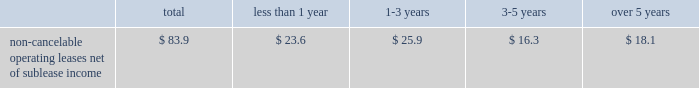Building .
The construction of the building was completed in december 2003 .
Due to lower than expected financing and construction costs , the final lease balance was lowered to $ 103.0 million .
As part of the agreement , we entered into a five-year lease that began upon the completion of the building .
At the end of the lease term , we can purchase the building for the lease balance , remarket or relinquish the building .
If we choose to remarket or are required to do so upon relinquishing the building , we are bound to arrange the sale of the building to an unrelated party and will be required to pay the lessor any shortfall between the net remarketing proceeds and the lease balance , up to the maximum recourse amount of $ 90.8 million ( 201cresidual value guarantee 201d ) .
See note 14 in our notes to consolidated financial statements for further information .
In august 1999 , we entered into a five-year lease agreement for our other two office buildings that currently serve as our corporate headquarters in san jose , california .
Under the agreement , we have the option to purchase the buildings at any time during the lease term for the lease balance , which is approximately $ 142.5 million .
We are in the process of evaluating alternative financing methods at expiration of the lease in fiscal 2004 and believe that several suitable financing options will be available to us .
At the end of the lease term , we can purchase the buildings for the lease balance , remarket or relinquish the buildings .
If we choose to remarket or are required to do so upon relinquishing the buildings , we are bound to arrange the sale of the buildings to an unrelated party and will be required to pay the lessor any shortfall between the net remarketing proceeds and the lease balance , up to the maximum recourse amount of $ 132.6 million ( 201cresidual value guarantee 201d ) .
For further information , see note 14 in our notes to consolidated financial statements .
The two lease agreements discussed above are subject to standard financial covenants .
The agreements limit the amount of indebtedness we can incur .
A leverage covenant requires us to keep our debt to ebitda ratio less than 2.5:1.0 .
As of november 28 , 2003 , our debt to ebitda ratio was 0.53:1.0 , well within the limit .
We also have a liquidity covenant which requires us to maintain a quick ratio equal to or greater than 1.0 .
As of november 28 , 2003 , our quick ratio was 2.2 , well above the minimum .
We expect to remain within compliance in the next 12 months .
We are comfortable with these limitations and believe they will not impact our cash or credit in the coming year or restrict our ability to execute our business plan .
The table summarizes our contractual commitments as of november 28 , 2003 : less than over total 1 year 1 2013 3 years 3-5 years 5 years non-cancelable operating leases , net of sublease income ................ .
$ 83.9 $ 23.6 $ 25.9 $ 16.3 $ 18.1 indemnifications in the normal course of business , we provide indemnifications of varying scope to customers against claims of intellectual property infringement made by third parties arising from the use of our products .
Historically , costs related to these indemnification provisions have not been significant and we are unable to estimate the maximum potential impact of these indemnification provisions on our future results of operations .
We have commitments to make certain milestone and/or retention payments typically entered into in conjunction with various acquisitions , for which we have made accruals in our consolidated financial statements .
In connection with our purchases of technology assets during fiscal 2003 , we entered into employee retention agreements totaling $ 2.2 million .
We are required to make payments upon satisfaction of certain conditions in the agreements .
As permitted under delaware law , we have agreements whereby we indemnify our officers and directors for certain events or occurrences while the officer or director is , or was serving , at our request in such capacity .
The indemnification period covers all pertinent events and occurrences during the officer 2019s or director 2019s lifetime .
The maximum potential amount of future payments we could be required to make under these indemnification agreements is unlimited ; however , we have director and officer insurance coverage that limits our exposure and enables us to recover a portion of any future amounts paid .
We believe the estimated fair value of these indemnification agreements in excess of applicable insurance coverage is minimal. .
Building .
The construction of the building was completed in december 2003 .
Due to lower than expected financing and construction costs , the final lease balance was lowered to $ 103.0 million .
As part of the agreement , we entered into a five-year lease that began upon the completion of the building .
At the end of the lease term , we can purchase the building for the lease balance , remarket or relinquish the building .
If we choose to remarket or are required to do so upon relinquishing the building , we are bound to arrange the sale of the building to an unrelated party and will be required to pay the lessor any shortfall between the net remarketing proceeds and the lease balance , up to the maximum recourse amount of $ 90.8 million ( 201cresidual value guarantee 201d ) .
See note 14 in our notes to consolidated financial statements for further information .
In august 1999 , we entered into a five-year lease agreement for our other two office buildings that currently serve as our corporate headquarters in san jose , california .
Under the agreement , we have the option to purchase the buildings at any time during the lease term for the lease balance , which is approximately $ 142.5 million .
We are in the process of evaluating alternative financing methods at expiration of the lease in fiscal 2004 and believe that several suitable financing options will be available to us .
At the end of the lease term , we can purchase the buildings for the lease balance , remarket or relinquish the buildings .
If we choose to remarket or are required to do so upon relinquishing the buildings , we are bound to arrange the sale of the buildings to an unrelated party and will be required to pay the lessor any shortfall between the net remarketing proceeds and the lease balance , up to the maximum recourse amount of $ 132.6 million ( 201cresidual value guarantee 201d ) .
For further information , see note 14 in our notes to consolidated financial statements .
The two lease agreements discussed above are subject to standard financial covenants .
The agreements limit the amount of indebtedness we can incur .
A leverage covenant requires us to keep our debt to ebitda ratio less than 2.5:1.0 .
As of november 28 , 2003 , our debt to ebitda ratio was 0.53:1.0 , well within the limit .
We also have a liquidity covenant which requires us to maintain a quick ratio equal to or greater than 1.0 .
As of november 28 , 2003 , our quick ratio was 2.2 , well above the minimum .
We expect to remain within compliance in the next 12 months .
We are comfortable with these limitations and believe they will not impact our cash or credit in the coming year or restrict our ability to execute our business plan .
The following table summarizes our contractual commitments as of november 28 , 2003 : less than over total 1 year 1 2013 3 years 3-5 years 5 years non-cancelable operating leases , net of sublease income ................ .
$ 83.9 $ 23.6 $ 25.9 $ 16.3 $ 18.1 indemnifications in the normal course of business , we provide indemnifications of varying scope to customers against claims of intellectual property infringement made by third parties arising from the use of our products .
Historically , costs related to these indemnification provisions have not been significant and we are unable to estimate the maximum potential impact of these indemnification provisions on our future results of operations .
We have commitments to make certain milestone and/or retention payments typically entered into in conjunction with various acquisitions , for which we have made accruals in our consolidated financial statements .
In connection with our purchases of technology assets during fiscal 2003 , we entered into employee retention agreements totaling $ 2.2 million .
We are required to make payments upon satisfaction of certain conditions in the agreements .
As permitted under delaware law , we have agreements whereby we indemnify our officers and directors for certain events or occurrences while the officer or director is , or was serving , at our request in such capacity .
The indemnification period covers all pertinent events and occurrences during the officer 2019s or director 2019s lifetime .
The maximum potential amount of future payments we could be required to make under these indemnification agreements is unlimited ; however , we have director and officer insurance coverage that limits our exposure and enables us to recover a portion of any future amounts paid .
We believe the estimated fair value of these indemnification agreements in excess of applicable insurance coverage is minimal. .
What percent of non-cancelable operating leases net of sublease income are due in greater than five years?\\n? 
Computations: (18.1 / 83.9)
Answer: 0.21573. 